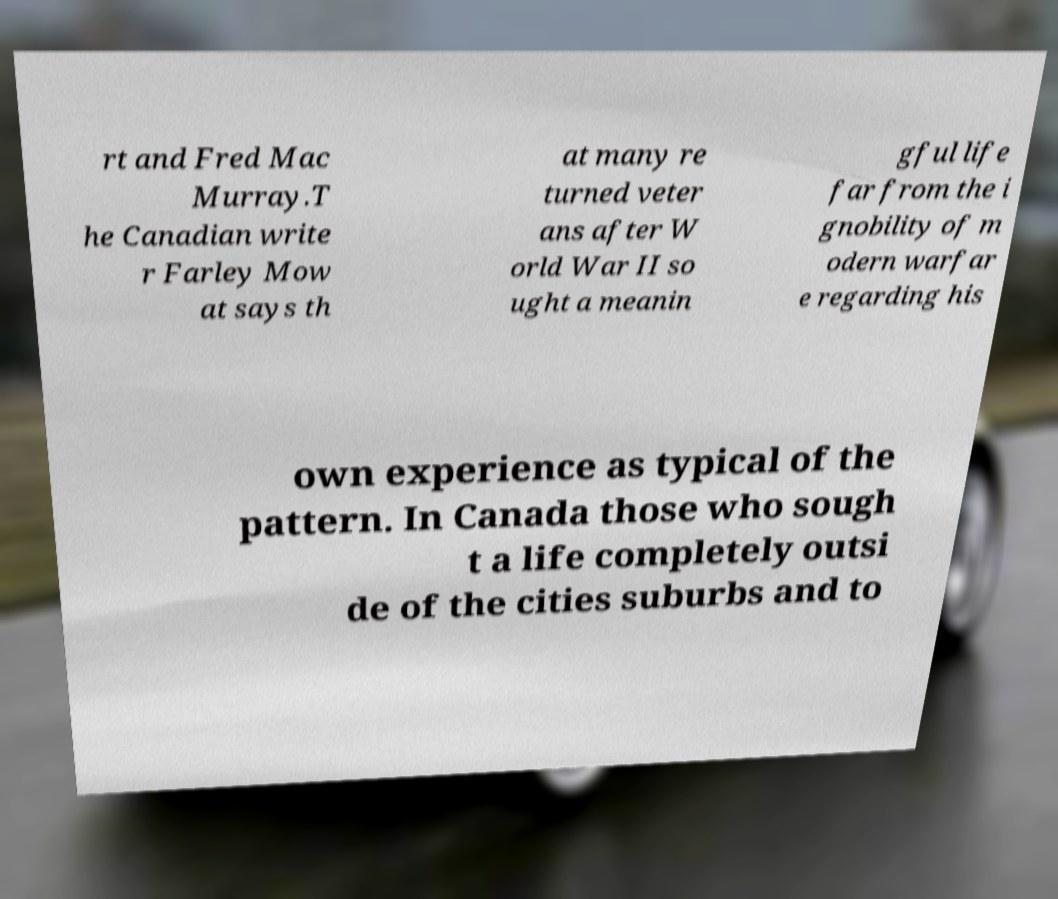Can you read and provide the text displayed in the image?This photo seems to have some interesting text. Can you extract and type it out for me? rt and Fred Mac Murray.T he Canadian write r Farley Mow at says th at many re turned veter ans after W orld War II so ught a meanin gful life far from the i gnobility of m odern warfar e regarding his own experience as typical of the pattern. In Canada those who sough t a life completely outsi de of the cities suburbs and to 